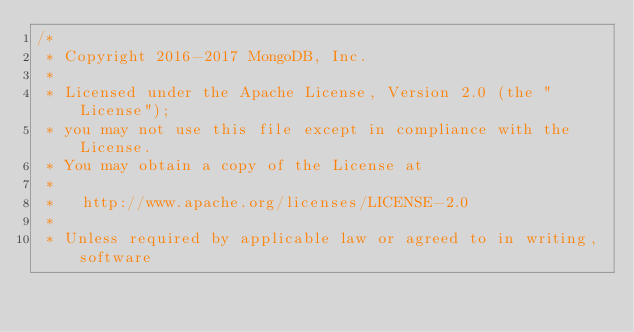<code> <loc_0><loc_0><loc_500><loc_500><_C_>/*
 * Copyright 2016-2017 MongoDB, Inc.
 *
 * Licensed under the Apache License, Version 2.0 (the "License");
 * you may not use this file except in compliance with the License.
 * You may obtain a copy of the License at
 *
 *   http://www.apache.org/licenses/LICENSE-2.0
 *
 * Unless required by applicable law or agreed to in writing, software</code> 